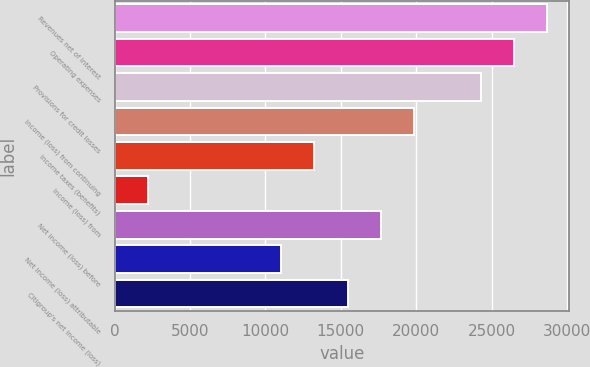<chart> <loc_0><loc_0><loc_500><loc_500><bar_chart><fcel>Revenues net of interest<fcel>Operating expenses<fcel>Provisions for credit losses<fcel>Income (loss) from continuing<fcel>Income taxes (benefits)<fcel>Income (loss) from<fcel>Net income (loss) before<fcel>Net income (loss) attributable<fcel>Citigroup's net income (loss)<nl><fcel>28692.3<fcel>26485.2<fcel>24278.1<fcel>19863.9<fcel>13242.6<fcel>2207.18<fcel>17656.8<fcel>11035.5<fcel>15449.7<nl></chart> 